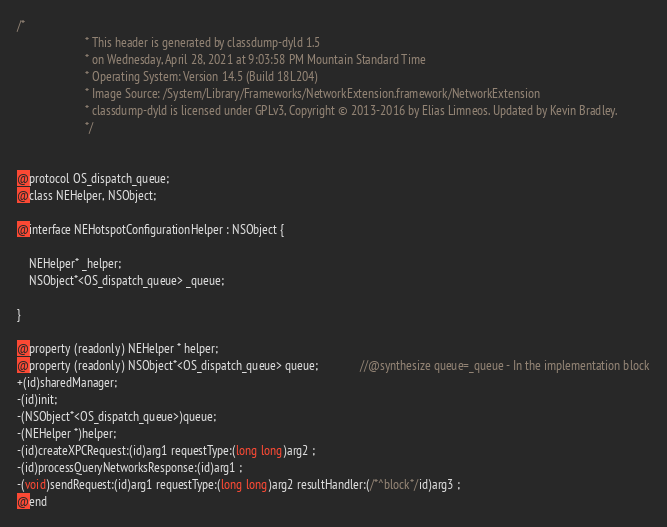Convert code to text. <code><loc_0><loc_0><loc_500><loc_500><_C_>/*
                       * This header is generated by classdump-dyld 1.5
                       * on Wednesday, April 28, 2021 at 9:03:58 PM Mountain Standard Time
                       * Operating System: Version 14.5 (Build 18L204)
                       * Image Source: /System/Library/Frameworks/NetworkExtension.framework/NetworkExtension
                       * classdump-dyld is licensed under GPLv3, Copyright © 2013-2016 by Elias Limneos. Updated by Kevin Bradley.
                       */


@protocol OS_dispatch_queue;
@class NEHelper, NSObject;

@interface NEHotspotConfigurationHelper : NSObject {

	NEHelper* _helper;
	NSObject*<OS_dispatch_queue> _queue;

}

@property (readonly) NEHelper * helper; 
@property (readonly) NSObject*<OS_dispatch_queue> queue;              //@synthesize queue=_queue - In the implementation block
+(id)sharedManager;
-(id)init;
-(NSObject*<OS_dispatch_queue>)queue;
-(NEHelper *)helper;
-(id)createXPCRequest:(id)arg1 requestType:(long long)arg2 ;
-(id)processQueryNetworksResponse:(id)arg1 ;
-(void)sendRequest:(id)arg1 requestType:(long long)arg2 resultHandler:(/*^block*/id)arg3 ;
@end

</code> 